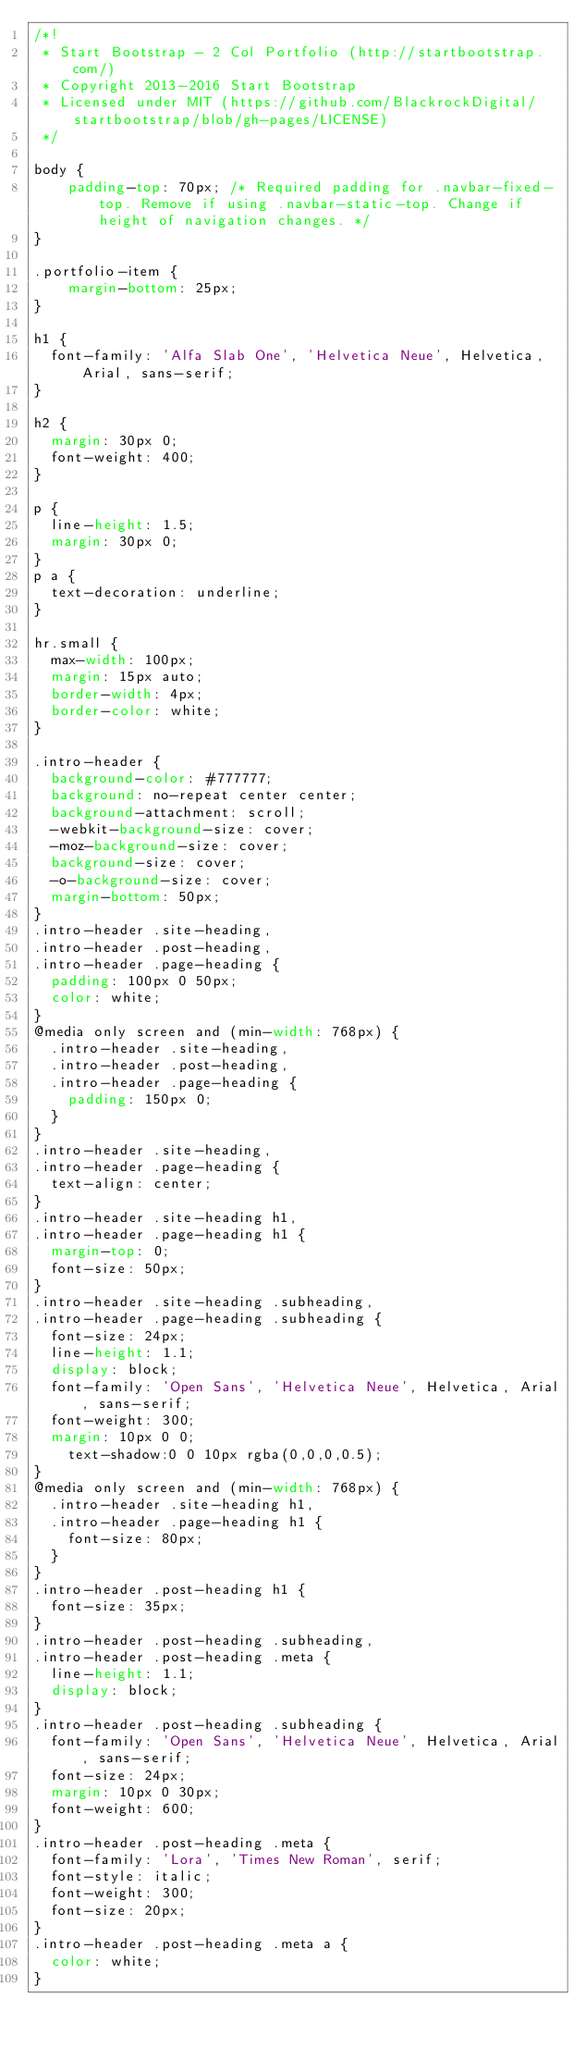Convert code to text. <code><loc_0><loc_0><loc_500><loc_500><_CSS_>/*!
 * Start Bootstrap - 2 Col Portfolio (http://startbootstrap.com/)
 * Copyright 2013-2016 Start Bootstrap
 * Licensed under MIT (https://github.com/BlackrockDigital/startbootstrap/blob/gh-pages/LICENSE)
 */

body {
    padding-top: 70px; /* Required padding for .navbar-fixed-top. Remove if using .navbar-static-top. Change if height of navigation changes. */
}

.portfolio-item {
    margin-bottom: 25px;
}

h1 {
  font-family: 'Alfa Slab One', 'Helvetica Neue', Helvetica, Arial, sans-serif;
}

h2 {
  margin: 30px 0;
  font-weight: 400;
}

p {
  line-height: 1.5;
  margin: 30px 0;
}
p a {
  text-decoration: underline;
}

hr.small {
  max-width: 100px;
  margin: 15px auto;
  border-width: 4px;
  border-color: white;
}

.intro-header {
  background-color: #777777;
  background: no-repeat center center;
  background-attachment: scroll;
  -webkit-background-size: cover;
  -moz-background-size: cover;
  background-size: cover;
  -o-background-size: cover;
  margin-bottom: 50px;
}
.intro-header .site-heading,
.intro-header .post-heading,
.intro-header .page-heading {
  padding: 100px 0 50px;
  color: white;
}
@media only screen and (min-width: 768px) {
  .intro-header .site-heading,
  .intro-header .post-heading,
  .intro-header .page-heading {
    padding: 150px 0;
  }
}
.intro-header .site-heading,
.intro-header .page-heading {
  text-align: center;
}
.intro-header .site-heading h1,
.intro-header .page-heading h1 {
  margin-top: 0;
  font-size: 50px;
}
.intro-header .site-heading .subheading,
.intro-header .page-heading .subheading {
  font-size: 24px;
  line-height: 1.1;
  display: block;
  font-family: 'Open Sans', 'Helvetica Neue', Helvetica, Arial, sans-serif;
  font-weight: 300;
  margin: 10px 0 0;
    text-shadow:0 0 10px rgba(0,0,0,0.5);
}
@media only screen and (min-width: 768px) {
  .intro-header .site-heading h1,
  .intro-header .page-heading h1 {
    font-size: 80px;
  }
}
.intro-header .post-heading h1 {
  font-size: 35px;
}
.intro-header .post-heading .subheading,
.intro-header .post-heading .meta {
  line-height: 1.1;
  display: block;
}
.intro-header .post-heading .subheading {
  font-family: 'Open Sans', 'Helvetica Neue', Helvetica, Arial, sans-serif;
  font-size: 24px;
  margin: 10px 0 30px;
  font-weight: 600;
}
.intro-header .post-heading .meta {
  font-family: 'Lora', 'Times New Roman', serif;
  font-style: italic;
  font-weight: 300;
  font-size: 20px;
}
.intro-header .post-heading .meta a {
  color: white;
}</code> 